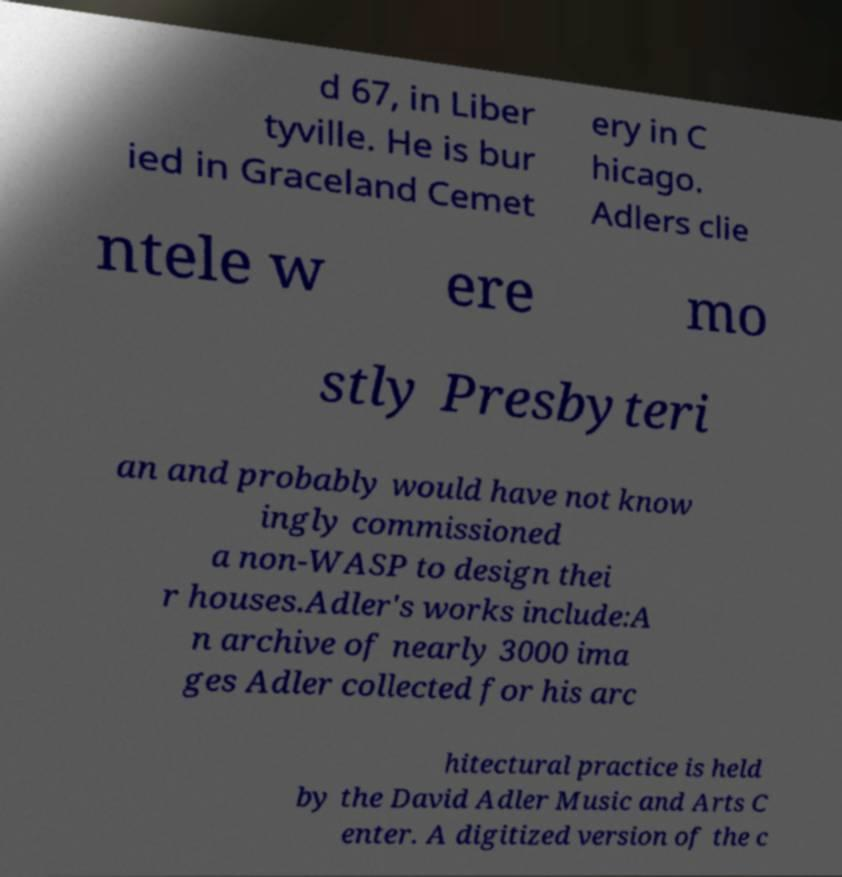Can you accurately transcribe the text from the provided image for me? d 67, in Liber tyville. He is bur ied in Graceland Cemet ery in C hicago. Adlers clie ntele w ere mo stly Presbyteri an and probably would have not know ingly commissioned a non-WASP to design thei r houses.Adler's works include:A n archive of nearly 3000 ima ges Adler collected for his arc hitectural practice is held by the David Adler Music and Arts C enter. A digitized version of the c 